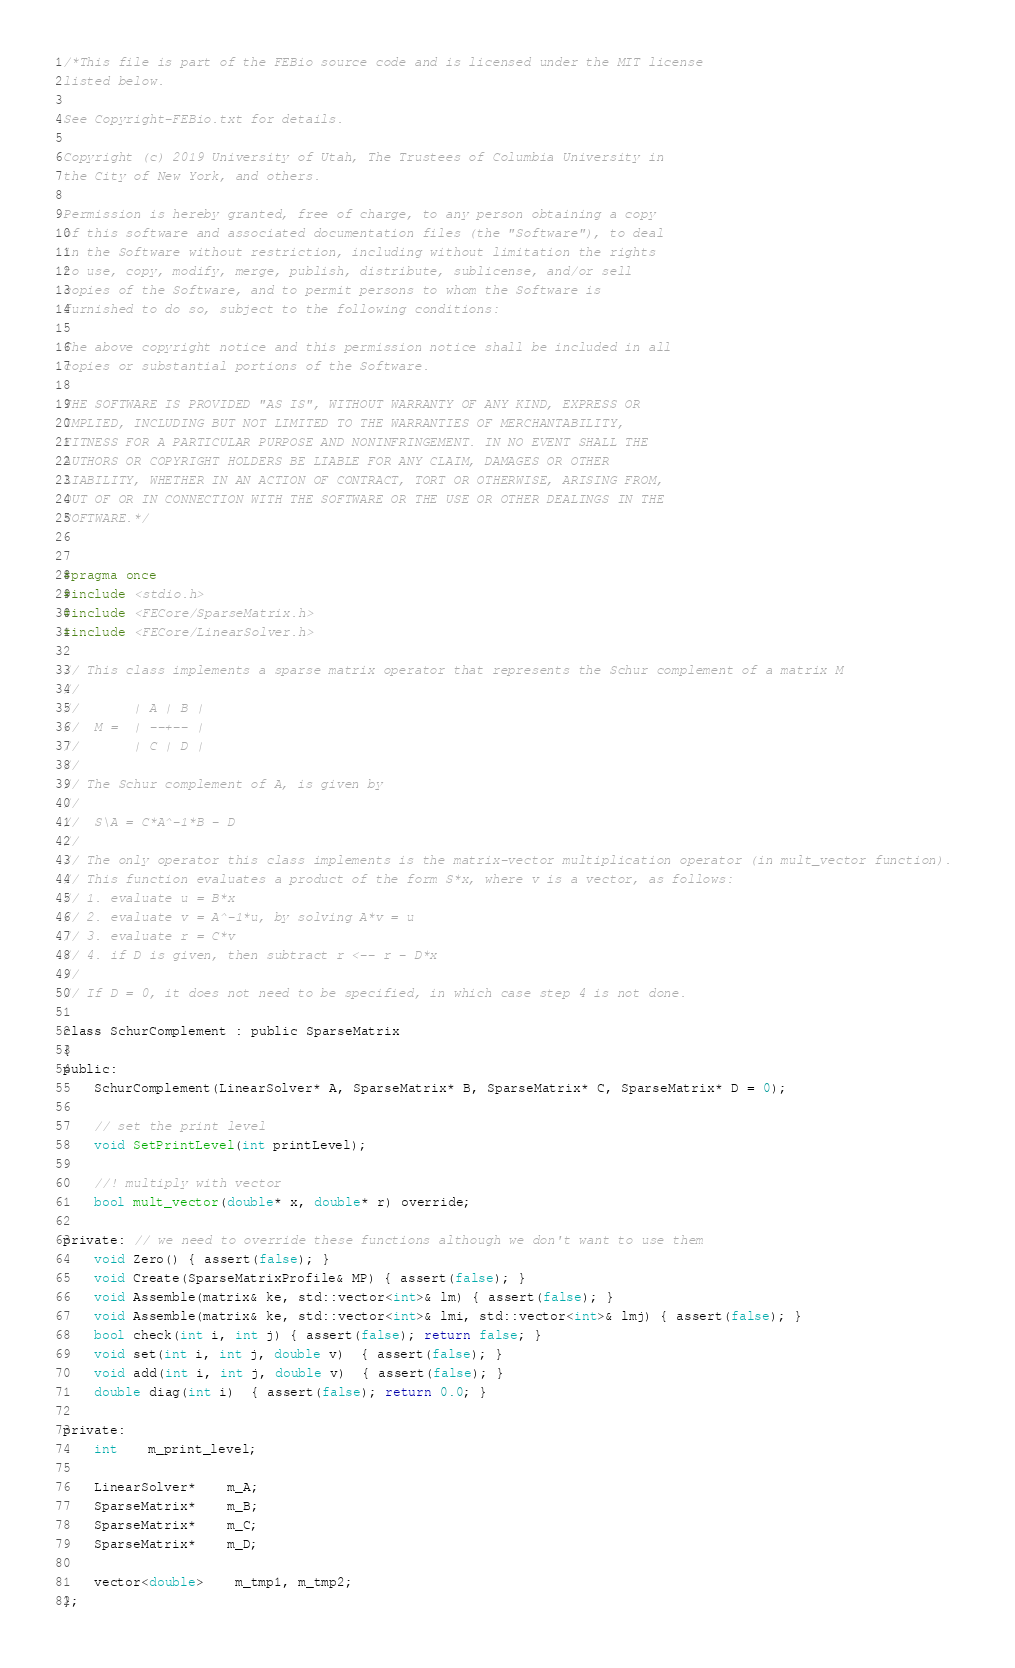<code> <loc_0><loc_0><loc_500><loc_500><_C_>/*This file is part of the FEBio source code and is licensed under the MIT license
listed below.

See Copyright-FEBio.txt for details.

Copyright (c) 2019 University of Utah, The Trustees of Columbia University in 
the City of New York, and others.

Permission is hereby granted, free of charge, to any person obtaining a copy
of this software and associated documentation files (the "Software"), to deal
in the Software without restriction, including without limitation the rights
to use, copy, modify, merge, publish, distribute, sublicense, and/or sell
copies of the Software, and to permit persons to whom the Software is
furnished to do so, subject to the following conditions:

The above copyright notice and this permission notice shall be included in all
copies or substantial portions of the Software.

THE SOFTWARE IS PROVIDED "AS IS", WITHOUT WARRANTY OF ANY KIND, EXPRESS OR
IMPLIED, INCLUDING BUT NOT LIMITED TO THE WARRANTIES OF MERCHANTABILITY,
FITNESS FOR A PARTICULAR PURPOSE AND NONINFRINGEMENT. IN NO EVENT SHALL THE
AUTHORS OR COPYRIGHT HOLDERS BE LIABLE FOR ANY CLAIM, DAMAGES OR OTHER
LIABILITY, WHETHER IN AN ACTION OF CONTRACT, TORT OR OTHERWISE, ARISING FROM,
OUT OF OR IN CONNECTION WITH THE SOFTWARE OR THE USE OR OTHER DEALINGS IN THE
SOFTWARE.*/


#pragma once
#include <stdio.h>
#include <FECore/SparseMatrix.h>
#include <FECore/LinearSolver.h>

// This class implements a sparse matrix operator that represents the Schur complement of a matrix M
//
//       | A | B |
//  M =  | --+-- |
//       | C | D |
//
// The Schur complement of A, is given by 
//       
//  S\A = C*A^-1*B - D
//
// The only operator this class implements is the matrix-vector multiplication operator (in mult_vector function). 
// This function evaluates a product of the form S*x, where v is a vector, as follows:
// 1. evaluate u = B*x
// 2. evaluate v = A^-1*u, by solving A*v = u
// 3. evaluate r = C*v
// 4. if D is given, then subtract r <-- r - D*x
//
// If D = 0, it does not need to be specified, in which case step 4 is not done.

class SchurComplement : public SparseMatrix
{
public:
	SchurComplement(LinearSolver* A, SparseMatrix* B, SparseMatrix* C, SparseMatrix* D = 0);

	// set the print level
	void SetPrintLevel(int printLevel);

	//! multiply with vector
	bool mult_vector(double* x, double* r) override;

private: // we need to override these functions although we don't want to use them
	void Zero() { assert(false); }
	void Create(SparseMatrixProfile& MP) { assert(false); }
	void Assemble(matrix& ke, std::vector<int>& lm) { assert(false); }
	void Assemble(matrix& ke, std::vector<int>& lmi, std::vector<int>& lmj) { assert(false); }
	bool check(int i, int j) { assert(false); return false; }
	void set(int i, int j, double v)  { assert(false); }
	void add(int i, int j, double v)  { assert(false); }
	double diag(int i)  { assert(false); return 0.0; }

private:
	int	m_print_level;
	
	LinearSolver*	m_A;
	SparseMatrix*	m_B;
	SparseMatrix*	m_C;
	SparseMatrix*	m_D;

	vector<double>	m_tmp1, m_tmp2;
};
</code> 